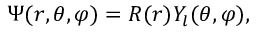Convert formula to latex. <formula><loc_0><loc_0><loc_500><loc_500>\Psi ( r , \theta , \varphi ) = R ( r ) Y _ { l } ( \theta , \varphi ) ,</formula> 